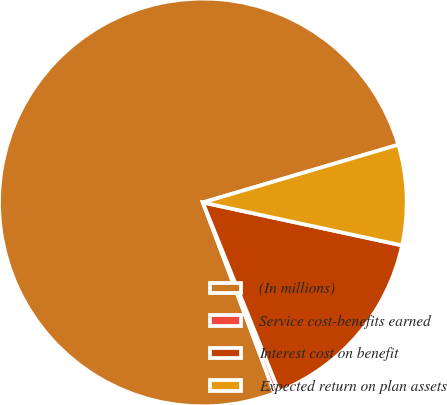Convert chart. <chart><loc_0><loc_0><loc_500><loc_500><pie_chart><fcel>(In millions)<fcel>Service cost-benefits earned<fcel>Interest cost on benefit<fcel>Expected return on plan assets<nl><fcel>76.15%<fcel>0.37%<fcel>15.53%<fcel>7.95%<nl></chart> 